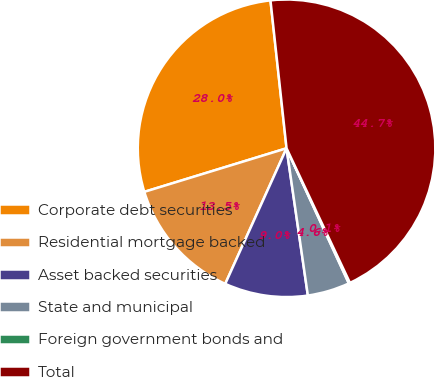<chart> <loc_0><loc_0><loc_500><loc_500><pie_chart><fcel>Corporate debt securities<fcel>Residential mortgage backed<fcel>Asset backed securities<fcel>State and municipal<fcel>Foreign government bonds and<fcel>Total<nl><fcel>28.01%<fcel>13.51%<fcel>9.05%<fcel>4.59%<fcel>0.13%<fcel>44.72%<nl></chart> 